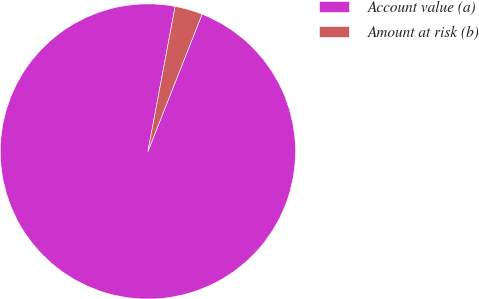Convert chart to OTSL. <chart><loc_0><loc_0><loc_500><loc_500><pie_chart><fcel>Account value (a)<fcel>Amount at risk (b)<nl><fcel>96.97%<fcel>3.03%<nl></chart> 